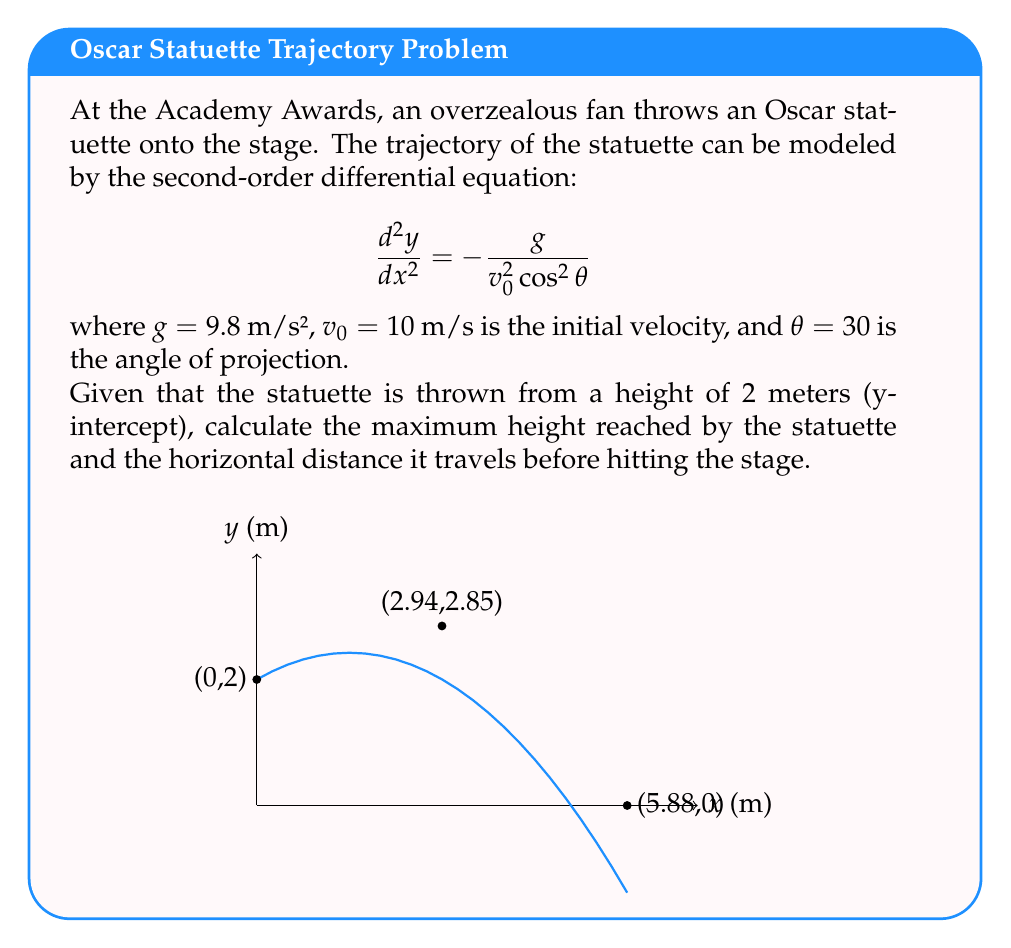Help me with this question. Let's solve this step-by-step:

1) The general solution for this differential equation is:

   $$y = -\frac{g}{2v_0^2 \cos^2\theta}x^2 + (\tan\theta)x + C$$

2) Substitute the given values:
   $g = 9.8$ m/s², $v_0 = 10$ m/s, $\theta = 30°$

   $$y = -\frac{9.8}{2(10^2)\cos^2(30°)}x^2 + \tan(30°)x + C$$
   $$y = -0.196x^2 + 0.577x + C$$

3) Use the initial condition (y-intercept = 2m) to find C:
   When x = 0, y = 2
   $2 = -0.196(0)^2 + 0.577(0) + C$
   $C = 2$

4) The final equation of the trajectory is:
   $$y = -0.196x^2 + 0.577x + 2$$

5) To find the maximum height, differentiate y with respect to x and set it to zero:
   $$\frac{dy}{dx} = -0.392x + 0.577 = 0$$
   $$x = \frac{0.577}{0.392} = 1.47$$

   The x-coordinate of the highest point is 1.47m.

6) Substitute this x-value back into the original equation to find the maximum height:
   $$y_{max} = -0.196(1.47)^2 + 0.577(1.47) + 2 = 2.85$$

   The maximum height is 2.85m.

7) To find where the statuette hits the stage, set y = 0 and solve for x:
   $$0 = -0.196x^2 + 0.577x + 2$$
   $$0.196x^2 - 0.577x - 2 = 0$$

   Using the quadratic formula:
   $$x = \frac{0.577 \pm \sqrt{0.577^2 + 4(0.196)(2)}}{2(0.196)}$$
   $$x = 5.88$$ (we take the positive root as it's the relevant solution)

   The statuette hits the stage 5.88m away from the throwing point.
Answer: Maximum height: 2.85m; Horizontal distance: 5.88m 